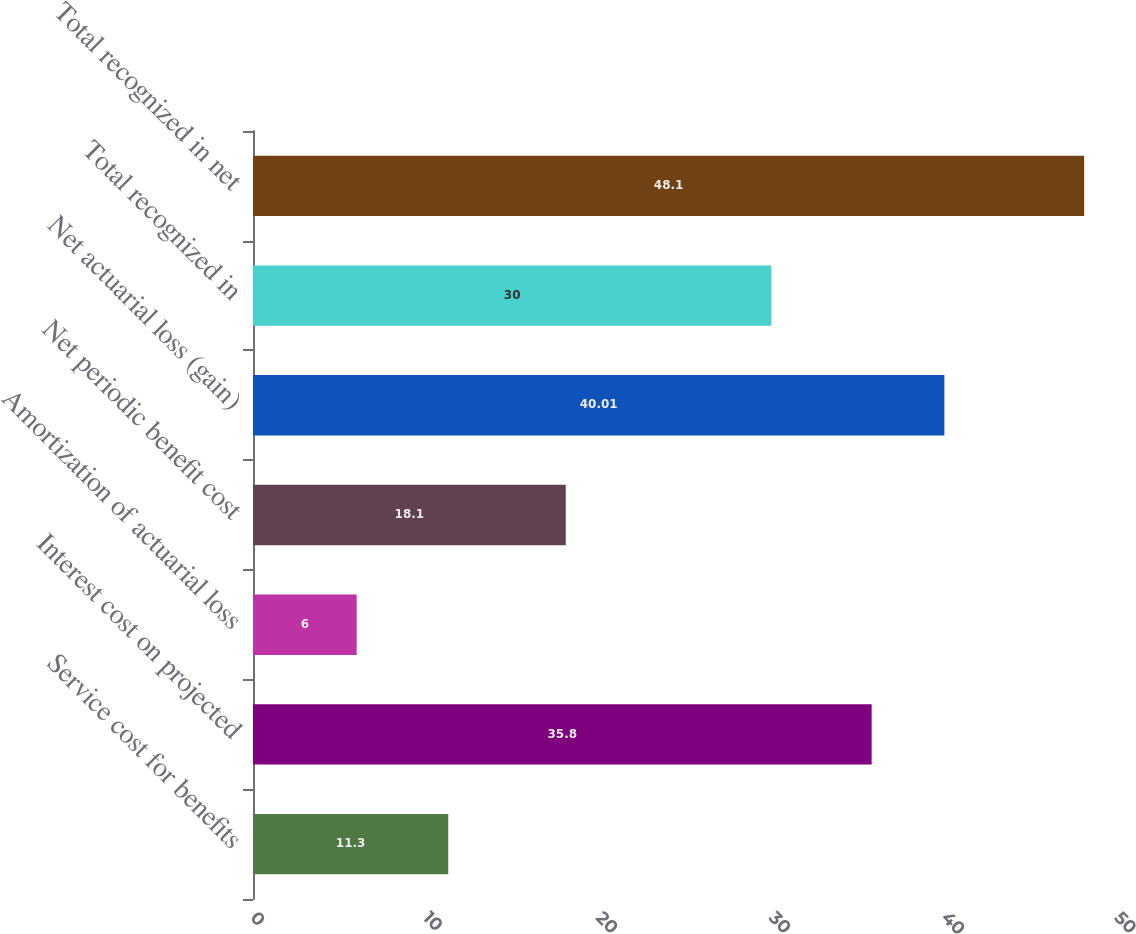Convert chart to OTSL. <chart><loc_0><loc_0><loc_500><loc_500><bar_chart><fcel>Service cost for benefits<fcel>Interest cost on projected<fcel>Amortization of actuarial loss<fcel>Net periodic benefit cost<fcel>Net actuarial loss (gain)<fcel>Total recognized in<fcel>Total recognized in net<nl><fcel>11.3<fcel>35.8<fcel>6<fcel>18.1<fcel>40.01<fcel>30<fcel>48.1<nl></chart> 